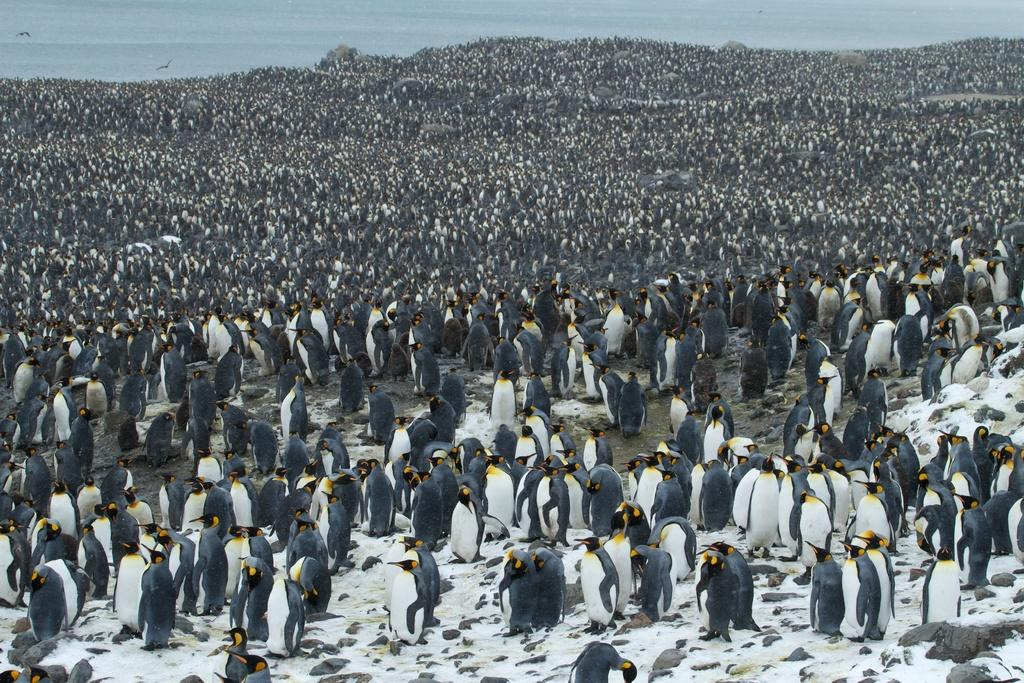What type of animals are present in the image? There are many penguins in the image. Where are the penguins located in relation to the ocean? The penguins are near the ocean. What can be seen in the background of the image? The ocean is visible in the background of the image. What is the surface on which the penguins are standing? There is a ground at the bottom of the image. What type of paint is being used to create the penguins in the image? The image does not depict a painting or any use of paint; it shows actual penguins near the ocean. 